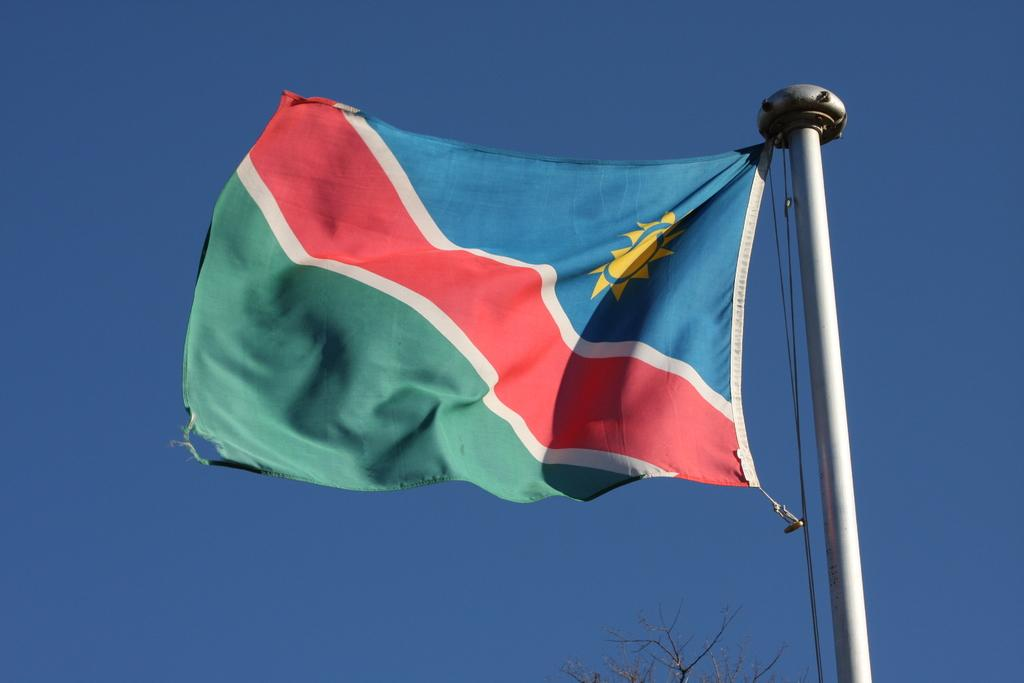What is the main subject in the center of the image? There is a flag in the center of the image. What other object can be seen at the bottom of the image? There is a tree at the bottom of the image. What can be seen in the background of the image? The sky is visible in the background of the image. What type of fiction is being performed on the stage in the image? There is no stage or fiction present in the image; it features a flag and a tree. How many wheels can be seen on the flag in the image? There are no wheels present on the flag in the image. 